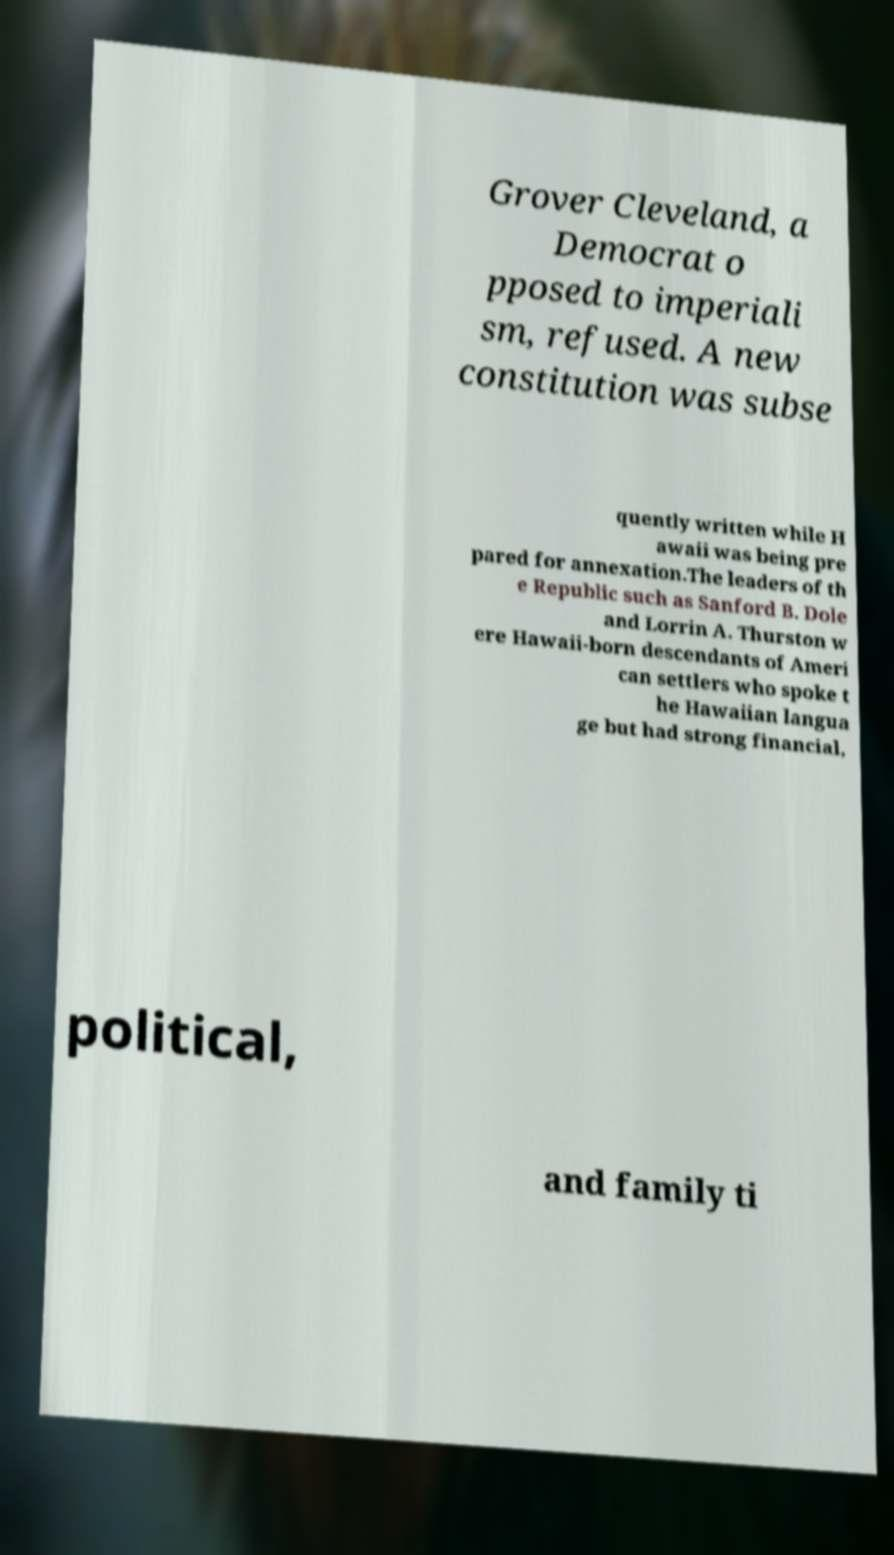Could you extract and type out the text from this image? Grover Cleveland, a Democrat o pposed to imperiali sm, refused. A new constitution was subse quently written while H awaii was being pre pared for annexation.The leaders of th e Republic such as Sanford B. Dole and Lorrin A. Thurston w ere Hawaii-born descendants of Ameri can settlers who spoke t he Hawaiian langua ge but had strong financial, political, and family ti 